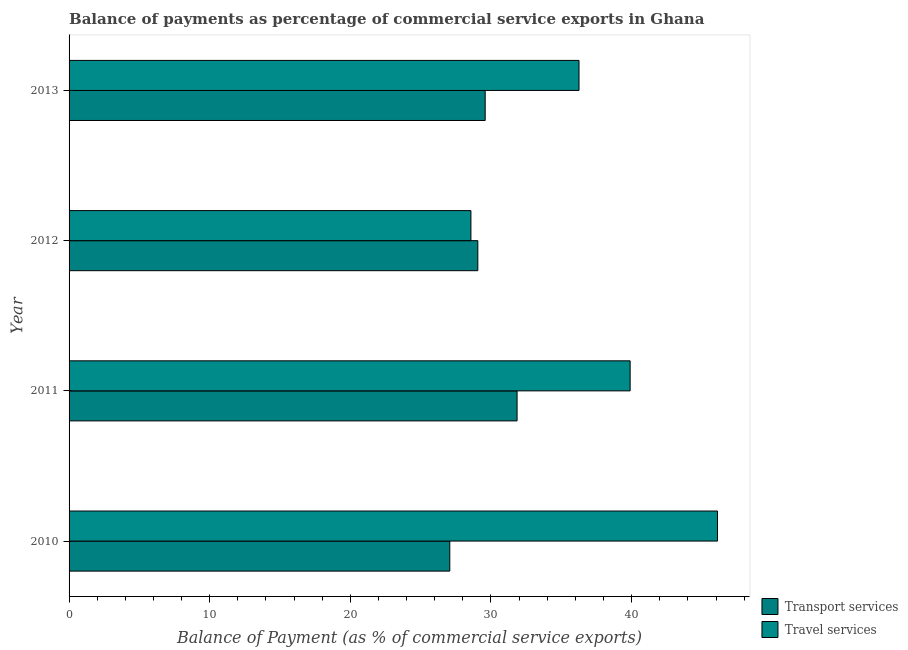How many different coloured bars are there?
Your answer should be very brief. 2. How many groups of bars are there?
Offer a terse response. 4. Are the number of bars per tick equal to the number of legend labels?
Provide a short and direct response. Yes. How many bars are there on the 1st tick from the top?
Your answer should be compact. 2. What is the balance of payments of transport services in 2010?
Your answer should be very brief. 27.07. Across all years, what is the maximum balance of payments of transport services?
Provide a short and direct response. 31.86. Across all years, what is the minimum balance of payments of transport services?
Make the answer very short. 27.07. What is the total balance of payments of transport services in the graph?
Provide a short and direct response. 117.58. What is the difference between the balance of payments of travel services in 2012 and that in 2013?
Your response must be concise. -7.69. What is the difference between the balance of payments of travel services in 2012 and the balance of payments of transport services in 2010?
Keep it short and to the point. 1.5. What is the average balance of payments of transport services per year?
Provide a succinct answer. 29.39. In the year 2012, what is the difference between the balance of payments of transport services and balance of payments of travel services?
Provide a short and direct response. 0.49. In how many years, is the balance of payments of transport services greater than 26 %?
Ensure brevity in your answer.  4. What is the difference between the highest and the second highest balance of payments of transport services?
Offer a very short reply. 2.27. What is the difference between the highest and the lowest balance of payments of transport services?
Your response must be concise. 4.78. Is the sum of the balance of payments of transport services in 2010 and 2013 greater than the maximum balance of payments of travel services across all years?
Ensure brevity in your answer.  Yes. What does the 2nd bar from the top in 2013 represents?
Offer a terse response. Transport services. What does the 2nd bar from the bottom in 2013 represents?
Your response must be concise. Travel services. How many bars are there?
Your response must be concise. 8. Are all the bars in the graph horizontal?
Your response must be concise. Yes. What is the difference between two consecutive major ticks on the X-axis?
Provide a short and direct response. 10. Are the values on the major ticks of X-axis written in scientific E-notation?
Provide a short and direct response. No. Does the graph contain any zero values?
Keep it short and to the point. No. Does the graph contain grids?
Your answer should be very brief. No. How are the legend labels stacked?
Your answer should be compact. Vertical. What is the title of the graph?
Keep it short and to the point. Balance of payments as percentage of commercial service exports in Ghana. What is the label or title of the X-axis?
Your response must be concise. Balance of Payment (as % of commercial service exports). What is the Balance of Payment (as % of commercial service exports) of Transport services in 2010?
Ensure brevity in your answer.  27.07. What is the Balance of Payment (as % of commercial service exports) in Travel services in 2010?
Offer a very short reply. 46.11. What is the Balance of Payment (as % of commercial service exports) of Transport services in 2011?
Keep it short and to the point. 31.86. What is the Balance of Payment (as % of commercial service exports) of Travel services in 2011?
Keep it short and to the point. 39.89. What is the Balance of Payment (as % of commercial service exports) in Transport services in 2012?
Offer a very short reply. 29.06. What is the Balance of Payment (as % of commercial service exports) of Travel services in 2012?
Offer a very short reply. 28.57. What is the Balance of Payment (as % of commercial service exports) of Transport services in 2013?
Keep it short and to the point. 29.59. What is the Balance of Payment (as % of commercial service exports) in Travel services in 2013?
Give a very brief answer. 36.26. Across all years, what is the maximum Balance of Payment (as % of commercial service exports) of Transport services?
Your answer should be compact. 31.86. Across all years, what is the maximum Balance of Payment (as % of commercial service exports) of Travel services?
Offer a terse response. 46.11. Across all years, what is the minimum Balance of Payment (as % of commercial service exports) in Transport services?
Offer a very short reply. 27.07. Across all years, what is the minimum Balance of Payment (as % of commercial service exports) of Travel services?
Make the answer very short. 28.57. What is the total Balance of Payment (as % of commercial service exports) in Transport services in the graph?
Provide a short and direct response. 117.58. What is the total Balance of Payment (as % of commercial service exports) of Travel services in the graph?
Give a very brief answer. 150.84. What is the difference between the Balance of Payment (as % of commercial service exports) in Transport services in 2010 and that in 2011?
Your answer should be very brief. -4.78. What is the difference between the Balance of Payment (as % of commercial service exports) in Travel services in 2010 and that in 2011?
Give a very brief answer. 6.21. What is the difference between the Balance of Payment (as % of commercial service exports) in Transport services in 2010 and that in 2012?
Your response must be concise. -1.99. What is the difference between the Balance of Payment (as % of commercial service exports) of Travel services in 2010 and that in 2012?
Provide a short and direct response. 17.53. What is the difference between the Balance of Payment (as % of commercial service exports) in Transport services in 2010 and that in 2013?
Offer a terse response. -2.52. What is the difference between the Balance of Payment (as % of commercial service exports) in Travel services in 2010 and that in 2013?
Your response must be concise. 9.85. What is the difference between the Balance of Payment (as % of commercial service exports) in Transport services in 2011 and that in 2012?
Give a very brief answer. 2.79. What is the difference between the Balance of Payment (as % of commercial service exports) of Travel services in 2011 and that in 2012?
Offer a terse response. 11.32. What is the difference between the Balance of Payment (as % of commercial service exports) of Transport services in 2011 and that in 2013?
Offer a terse response. 2.27. What is the difference between the Balance of Payment (as % of commercial service exports) in Travel services in 2011 and that in 2013?
Offer a terse response. 3.63. What is the difference between the Balance of Payment (as % of commercial service exports) of Transport services in 2012 and that in 2013?
Keep it short and to the point. -0.52. What is the difference between the Balance of Payment (as % of commercial service exports) of Travel services in 2012 and that in 2013?
Your response must be concise. -7.69. What is the difference between the Balance of Payment (as % of commercial service exports) of Transport services in 2010 and the Balance of Payment (as % of commercial service exports) of Travel services in 2011?
Offer a terse response. -12.82. What is the difference between the Balance of Payment (as % of commercial service exports) of Transport services in 2010 and the Balance of Payment (as % of commercial service exports) of Travel services in 2012?
Keep it short and to the point. -1.5. What is the difference between the Balance of Payment (as % of commercial service exports) of Transport services in 2010 and the Balance of Payment (as % of commercial service exports) of Travel services in 2013?
Provide a short and direct response. -9.19. What is the difference between the Balance of Payment (as % of commercial service exports) in Transport services in 2011 and the Balance of Payment (as % of commercial service exports) in Travel services in 2012?
Ensure brevity in your answer.  3.28. What is the difference between the Balance of Payment (as % of commercial service exports) of Transport services in 2011 and the Balance of Payment (as % of commercial service exports) of Travel services in 2013?
Offer a terse response. -4.4. What is the difference between the Balance of Payment (as % of commercial service exports) of Transport services in 2012 and the Balance of Payment (as % of commercial service exports) of Travel services in 2013?
Give a very brief answer. -7.2. What is the average Balance of Payment (as % of commercial service exports) of Transport services per year?
Provide a short and direct response. 29.39. What is the average Balance of Payment (as % of commercial service exports) of Travel services per year?
Offer a terse response. 37.71. In the year 2010, what is the difference between the Balance of Payment (as % of commercial service exports) in Transport services and Balance of Payment (as % of commercial service exports) in Travel services?
Provide a short and direct response. -19.04. In the year 2011, what is the difference between the Balance of Payment (as % of commercial service exports) in Transport services and Balance of Payment (as % of commercial service exports) in Travel services?
Make the answer very short. -8.04. In the year 2012, what is the difference between the Balance of Payment (as % of commercial service exports) in Transport services and Balance of Payment (as % of commercial service exports) in Travel services?
Ensure brevity in your answer.  0.49. In the year 2013, what is the difference between the Balance of Payment (as % of commercial service exports) of Transport services and Balance of Payment (as % of commercial service exports) of Travel services?
Offer a terse response. -6.67. What is the ratio of the Balance of Payment (as % of commercial service exports) of Transport services in 2010 to that in 2011?
Offer a very short reply. 0.85. What is the ratio of the Balance of Payment (as % of commercial service exports) of Travel services in 2010 to that in 2011?
Ensure brevity in your answer.  1.16. What is the ratio of the Balance of Payment (as % of commercial service exports) in Transport services in 2010 to that in 2012?
Provide a short and direct response. 0.93. What is the ratio of the Balance of Payment (as % of commercial service exports) in Travel services in 2010 to that in 2012?
Keep it short and to the point. 1.61. What is the ratio of the Balance of Payment (as % of commercial service exports) of Transport services in 2010 to that in 2013?
Make the answer very short. 0.91. What is the ratio of the Balance of Payment (as % of commercial service exports) in Travel services in 2010 to that in 2013?
Offer a very short reply. 1.27. What is the ratio of the Balance of Payment (as % of commercial service exports) in Transport services in 2011 to that in 2012?
Make the answer very short. 1.1. What is the ratio of the Balance of Payment (as % of commercial service exports) of Travel services in 2011 to that in 2012?
Offer a very short reply. 1.4. What is the ratio of the Balance of Payment (as % of commercial service exports) of Transport services in 2011 to that in 2013?
Offer a terse response. 1.08. What is the ratio of the Balance of Payment (as % of commercial service exports) of Travel services in 2011 to that in 2013?
Your response must be concise. 1.1. What is the ratio of the Balance of Payment (as % of commercial service exports) in Transport services in 2012 to that in 2013?
Your answer should be very brief. 0.98. What is the ratio of the Balance of Payment (as % of commercial service exports) in Travel services in 2012 to that in 2013?
Offer a terse response. 0.79. What is the difference between the highest and the second highest Balance of Payment (as % of commercial service exports) in Transport services?
Your answer should be compact. 2.27. What is the difference between the highest and the second highest Balance of Payment (as % of commercial service exports) of Travel services?
Your answer should be compact. 6.21. What is the difference between the highest and the lowest Balance of Payment (as % of commercial service exports) in Transport services?
Provide a succinct answer. 4.78. What is the difference between the highest and the lowest Balance of Payment (as % of commercial service exports) in Travel services?
Keep it short and to the point. 17.53. 